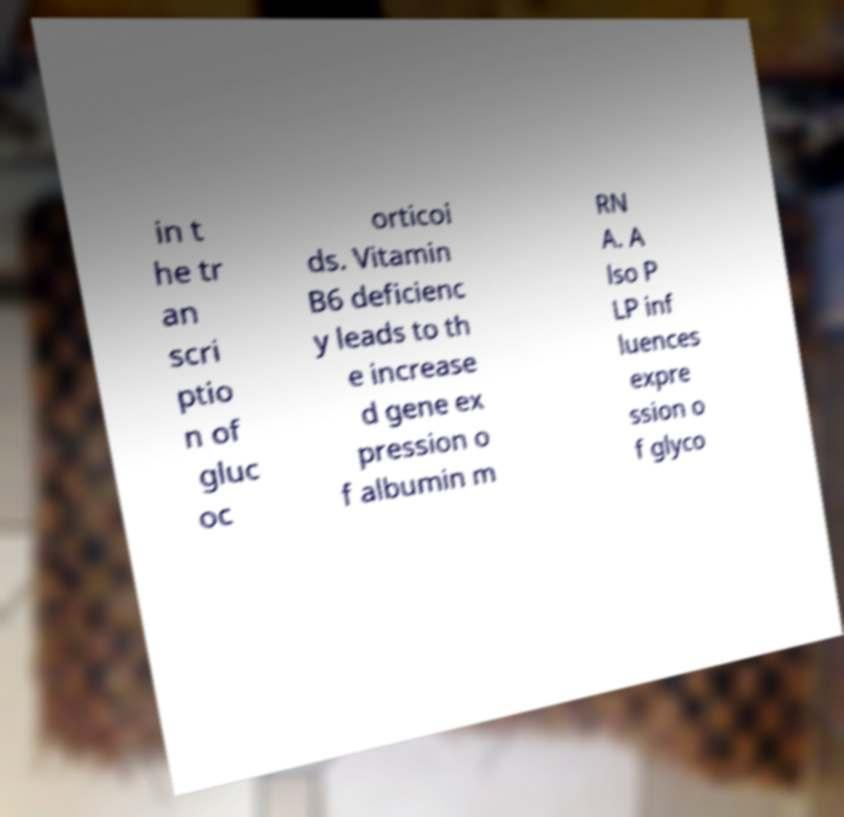Could you assist in decoding the text presented in this image and type it out clearly? in t he tr an scri ptio n of gluc oc orticoi ds. Vitamin B6 deficienc y leads to th e increase d gene ex pression o f albumin m RN A. A lso P LP inf luences expre ssion o f glyco 